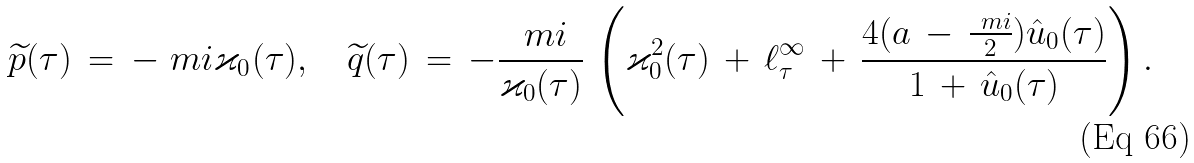Convert formula to latex. <formula><loc_0><loc_0><loc_500><loc_500>\widetilde { p } ( \tau ) \, = \, - \ m i \varkappa _ { 0 } ( \tau ) , \quad \widetilde { q } ( \tau ) \, = \, - \frac { \ m i } { \varkappa _ { 0 } ( \tau ) } \, \left ( \varkappa _ { 0 } ^ { 2 } ( \tau ) \, + \, \ell _ { \tau } ^ { \infty } \, + \, \frac { 4 ( a \, - \, \frac { \ m i } { 2 } ) \hat { u } _ { 0 } ( \tau ) } { 1 \, + \, \hat { u } _ { 0 } ( \tau ) } \right ) .</formula> 